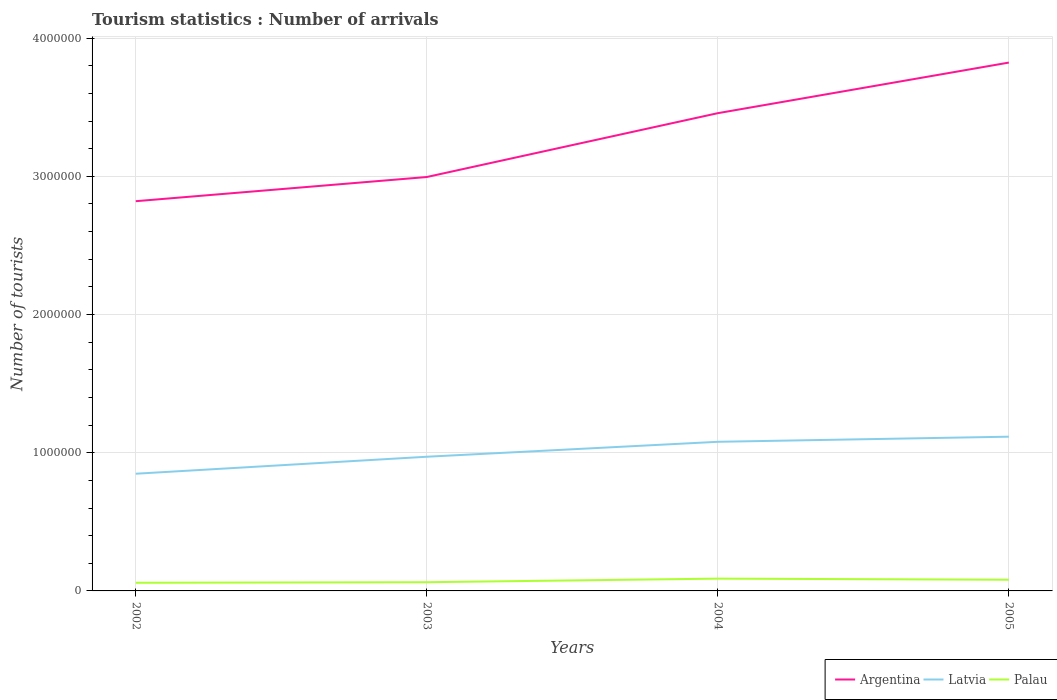How many different coloured lines are there?
Your answer should be very brief. 3. Across all years, what is the maximum number of tourist arrivals in Argentina?
Keep it short and to the point. 2.82e+06. What is the total number of tourist arrivals in Palau in the graph?
Offer a terse response. -3.00e+04. What is the difference between the highest and the second highest number of tourist arrivals in Latvia?
Make the answer very short. 2.68e+05. What is the difference between the highest and the lowest number of tourist arrivals in Palau?
Provide a succinct answer. 2. Is the number of tourist arrivals in Argentina strictly greater than the number of tourist arrivals in Palau over the years?
Make the answer very short. No. How many lines are there?
Provide a succinct answer. 3. Does the graph contain any zero values?
Your answer should be compact. No. How many legend labels are there?
Offer a terse response. 3. How are the legend labels stacked?
Ensure brevity in your answer.  Horizontal. What is the title of the graph?
Provide a short and direct response. Tourism statistics : Number of arrivals. What is the label or title of the Y-axis?
Your answer should be very brief. Number of tourists. What is the Number of tourists of Argentina in 2002?
Offer a very short reply. 2.82e+06. What is the Number of tourists of Latvia in 2002?
Provide a succinct answer. 8.48e+05. What is the Number of tourists of Palau in 2002?
Your answer should be very brief. 5.90e+04. What is the Number of tourists of Argentina in 2003?
Make the answer very short. 3.00e+06. What is the Number of tourists in Latvia in 2003?
Give a very brief answer. 9.71e+05. What is the Number of tourists in Palau in 2003?
Keep it short and to the point. 6.30e+04. What is the Number of tourists in Argentina in 2004?
Provide a short and direct response. 3.46e+06. What is the Number of tourists of Latvia in 2004?
Provide a short and direct response. 1.08e+06. What is the Number of tourists of Palau in 2004?
Make the answer very short. 8.90e+04. What is the Number of tourists of Argentina in 2005?
Your response must be concise. 3.82e+06. What is the Number of tourists in Latvia in 2005?
Your answer should be very brief. 1.12e+06. What is the Number of tourists of Palau in 2005?
Your answer should be very brief. 8.10e+04. Across all years, what is the maximum Number of tourists in Argentina?
Your response must be concise. 3.82e+06. Across all years, what is the maximum Number of tourists in Latvia?
Your answer should be compact. 1.12e+06. Across all years, what is the maximum Number of tourists of Palau?
Provide a short and direct response. 8.90e+04. Across all years, what is the minimum Number of tourists of Argentina?
Your response must be concise. 2.82e+06. Across all years, what is the minimum Number of tourists of Latvia?
Your answer should be compact. 8.48e+05. Across all years, what is the minimum Number of tourists of Palau?
Offer a terse response. 5.90e+04. What is the total Number of tourists in Argentina in the graph?
Your answer should be compact. 1.31e+07. What is the total Number of tourists of Latvia in the graph?
Provide a short and direct response. 4.01e+06. What is the total Number of tourists of Palau in the graph?
Make the answer very short. 2.92e+05. What is the difference between the Number of tourists in Argentina in 2002 and that in 2003?
Give a very brief answer. -1.75e+05. What is the difference between the Number of tourists in Latvia in 2002 and that in 2003?
Your response must be concise. -1.23e+05. What is the difference between the Number of tourists of Palau in 2002 and that in 2003?
Ensure brevity in your answer.  -4000. What is the difference between the Number of tourists of Argentina in 2002 and that in 2004?
Keep it short and to the point. -6.37e+05. What is the difference between the Number of tourists of Latvia in 2002 and that in 2004?
Ensure brevity in your answer.  -2.31e+05. What is the difference between the Number of tourists in Argentina in 2002 and that in 2005?
Ensure brevity in your answer.  -1.00e+06. What is the difference between the Number of tourists in Latvia in 2002 and that in 2005?
Provide a succinct answer. -2.68e+05. What is the difference between the Number of tourists in Palau in 2002 and that in 2005?
Your answer should be very brief. -2.20e+04. What is the difference between the Number of tourists in Argentina in 2003 and that in 2004?
Offer a terse response. -4.62e+05. What is the difference between the Number of tourists in Latvia in 2003 and that in 2004?
Offer a terse response. -1.08e+05. What is the difference between the Number of tourists in Palau in 2003 and that in 2004?
Offer a terse response. -2.60e+04. What is the difference between the Number of tourists of Argentina in 2003 and that in 2005?
Give a very brief answer. -8.28e+05. What is the difference between the Number of tourists of Latvia in 2003 and that in 2005?
Offer a terse response. -1.45e+05. What is the difference between the Number of tourists in Palau in 2003 and that in 2005?
Your answer should be compact. -1.80e+04. What is the difference between the Number of tourists of Argentina in 2004 and that in 2005?
Keep it short and to the point. -3.66e+05. What is the difference between the Number of tourists of Latvia in 2004 and that in 2005?
Give a very brief answer. -3.70e+04. What is the difference between the Number of tourists of Palau in 2004 and that in 2005?
Offer a terse response. 8000. What is the difference between the Number of tourists in Argentina in 2002 and the Number of tourists in Latvia in 2003?
Provide a short and direct response. 1.85e+06. What is the difference between the Number of tourists of Argentina in 2002 and the Number of tourists of Palau in 2003?
Your response must be concise. 2.76e+06. What is the difference between the Number of tourists of Latvia in 2002 and the Number of tourists of Palau in 2003?
Provide a short and direct response. 7.85e+05. What is the difference between the Number of tourists in Argentina in 2002 and the Number of tourists in Latvia in 2004?
Give a very brief answer. 1.74e+06. What is the difference between the Number of tourists in Argentina in 2002 and the Number of tourists in Palau in 2004?
Make the answer very short. 2.73e+06. What is the difference between the Number of tourists of Latvia in 2002 and the Number of tourists of Palau in 2004?
Provide a short and direct response. 7.59e+05. What is the difference between the Number of tourists of Argentina in 2002 and the Number of tourists of Latvia in 2005?
Your answer should be compact. 1.70e+06. What is the difference between the Number of tourists in Argentina in 2002 and the Number of tourists in Palau in 2005?
Your answer should be compact. 2.74e+06. What is the difference between the Number of tourists of Latvia in 2002 and the Number of tourists of Palau in 2005?
Offer a very short reply. 7.67e+05. What is the difference between the Number of tourists of Argentina in 2003 and the Number of tourists of Latvia in 2004?
Give a very brief answer. 1.92e+06. What is the difference between the Number of tourists of Argentina in 2003 and the Number of tourists of Palau in 2004?
Your response must be concise. 2.91e+06. What is the difference between the Number of tourists in Latvia in 2003 and the Number of tourists in Palau in 2004?
Make the answer very short. 8.82e+05. What is the difference between the Number of tourists of Argentina in 2003 and the Number of tourists of Latvia in 2005?
Your response must be concise. 1.88e+06. What is the difference between the Number of tourists of Argentina in 2003 and the Number of tourists of Palau in 2005?
Offer a very short reply. 2.91e+06. What is the difference between the Number of tourists in Latvia in 2003 and the Number of tourists in Palau in 2005?
Your answer should be compact. 8.90e+05. What is the difference between the Number of tourists in Argentina in 2004 and the Number of tourists in Latvia in 2005?
Offer a terse response. 2.34e+06. What is the difference between the Number of tourists in Argentina in 2004 and the Number of tourists in Palau in 2005?
Keep it short and to the point. 3.38e+06. What is the difference between the Number of tourists in Latvia in 2004 and the Number of tourists in Palau in 2005?
Make the answer very short. 9.98e+05. What is the average Number of tourists of Argentina per year?
Offer a terse response. 3.27e+06. What is the average Number of tourists of Latvia per year?
Give a very brief answer. 1.00e+06. What is the average Number of tourists in Palau per year?
Provide a short and direct response. 7.30e+04. In the year 2002, what is the difference between the Number of tourists in Argentina and Number of tourists in Latvia?
Your answer should be compact. 1.97e+06. In the year 2002, what is the difference between the Number of tourists in Argentina and Number of tourists in Palau?
Offer a terse response. 2.76e+06. In the year 2002, what is the difference between the Number of tourists in Latvia and Number of tourists in Palau?
Your response must be concise. 7.89e+05. In the year 2003, what is the difference between the Number of tourists of Argentina and Number of tourists of Latvia?
Your answer should be compact. 2.02e+06. In the year 2003, what is the difference between the Number of tourists in Argentina and Number of tourists in Palau?
Offer a terse response. 2.93e+06. In the year 2003, what is the difference between the Number of tourists of Latvia and Number of tourists of Palau?
Provide a short and direct response. 9.08e+05. In the year 2004, what is the difference between the Number of tourists of Argentina and Number of tourists of Latvia?
Make the answer very short. 2.38e+06. In the year 2004, what is the difference between the Number of tourists in Argentina and Number of tourists in Palau?
Offer a very short reply. 3.37e+06. In the year 2004, what is the difference between the Number of tourists of Latvia and Number of tourists of Palau?
Your answer should be compact. 9.90e+05. In the year 2005, what is the difference between the Number of tourists of Argentina and Number of tourists of Latvia?
Give a very brief answer. 2.71e+06. In the year 2005, what is the difference between the Number of tourists in Argentina and Number of tourists in Palau?
Provide a succinct answer. 3.74e+06. In the year 2005, what is the difference between the Number of tourists in Latvia and Number of tourists in Palau?
Provide a short and direct response. 1.04e+06. What is the ratio of the Number of tourists of Argentina in 2002 to that in 2003?
Your answer should be compact. 0.94. What is the ratio of the Number of tourists in Latvia in 2002 to that in 2003?
Your response must be concise. 0.87. What is the ratio of the Number of tourists of Palau in 2002 to that in 2003?
Ensure brevity in your answer.  0.94. What is the ratio of the Number of tourists in Argentina in 2002 to that in 2004?
Your answer should be very brief. 0.82. What is the ratio of the Number of tourists in Latvia in 2002 to that in 2004?
Offer a very short reply. 0.79. What is the ratio of the Number of tourists of Palau in 2002 to that in 2004?
Ensure brevity in your answer.  0.66. What is the ratio of the Number of tourists of Argentina in 2002 to that in 2005?
Provide a short and direct response. 0.74. What is the ratio of the Number of tourists of Latvia in 2002 to that in 2005?
Provide a short and direct response. 0.76. What is the ratio of the Number of tourists of Palau in 2002 to that in 2005?
Provide a short and direct response. 0.73. What is the ratio of the Number of tourists of Argentina in 2003 to that in 2004?
Give a very brief answer. 0.87. What is the ratio of the Number of tourists in Latvia in 2003 to that in 2004?
Your answer should be compact. 0.9. What is the ratio of the Number of tourists in Palau in 2003 to that in 2004?
Provide a succinct answer. 0.71. What is the ratio of the Number of tourists of Argentina in 2003 to that in 2005?
Your response must be concise. 0.78. What is the ratio of the Number of tourists of Latvia in 2003 to that in 2005?
Your response must be concise. 0.87. What is the ratio of the Number of tourists of Argentina in 2004 to that in 2005?
Your answer should be compact. 0.9. What is the ratio of the Number of tourists in Latvia in 2004 to that in 2005?
Make the answer very short. 0.97. What is the ratio of the Number of tourists of Palau in 2004 to that in 2005?
Your answer should be very brief. 1.1. What is the difference between the highest and the second highest Number of tourists of Argentina?
Provide a short and direct response. 3.66e+05. What is the difference between the highest and the second highest Number of tourists in Latvia?
Give a very brief answer. 3.70e+04. What is the difference between the highest and the second highest Number of tourists in Palau?
Your answer should be very brief. 8000. What is the difference between the highest and the lowest Number of tourists in Argentina?
Offer a very short reply. 1.00e+06. What is the difference between the highest and the lowest Number of tourists of Latvia?
Your answer should be very brief. 2.68e+05. What is the difference between the highest and the lowest Number of tourists of Palau?
Give a very brief answer. 3.00e+04. 